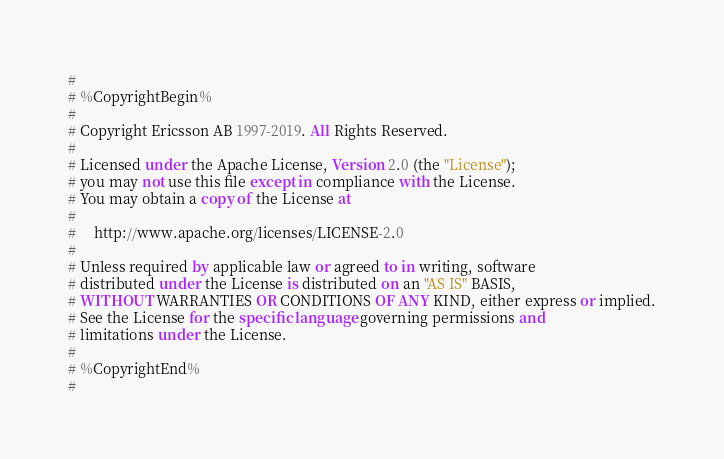<code> <loc_0><loc_0><loc_500><loc_500><_SQL_>#
# %CopyrightBegin%
#
# Copyright Ericsson AB 1997-2019. All Rights Reserved.
#
# Licensed under the Apache License, Version 2.0 (the "License");
# you may not use this file except in compliance with the License.
# You may obtain a copy of the License at
#
#     http://www.apache.org/licenses/LICENSE-2.0
#
# Unless required by applicable law or agreed to in writing, software
# distributed under the License is distributed on an "AS IS" BASIS,
# WITHOUT WARRANTIES OR CONDITIONS OF ANY KIND, either express or implied.
# See the License for the specific language governing permissions and
# limitations under the License.
#
# %CopyrightEnd%
#
</code> 